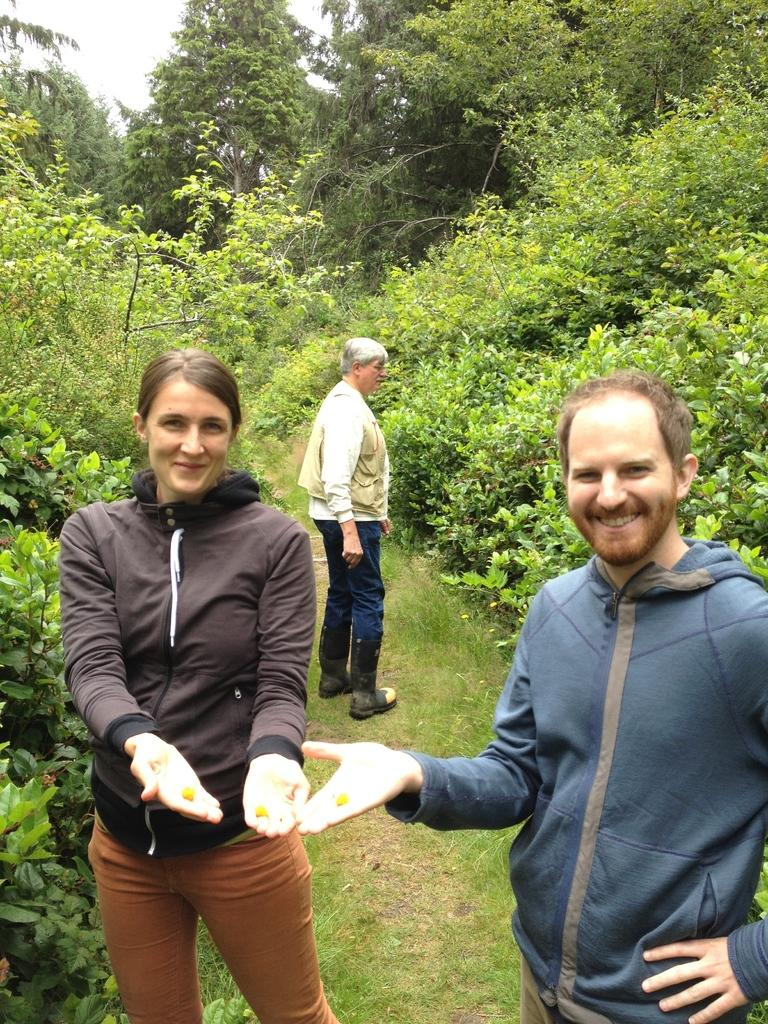How many people are in the image? There are three persons standing on the ground in the image. What are two of the persons holding in their hands? Two of the persons are holding objects in their hands. What can be seen in the background of the image? There are trees and the sky visible in the background of the image. What type of toothpaste is being used by the person on the left in the image? There is no toothpaste present in the image, as it features three persons standing on the ground with no reference to toothpaste. 